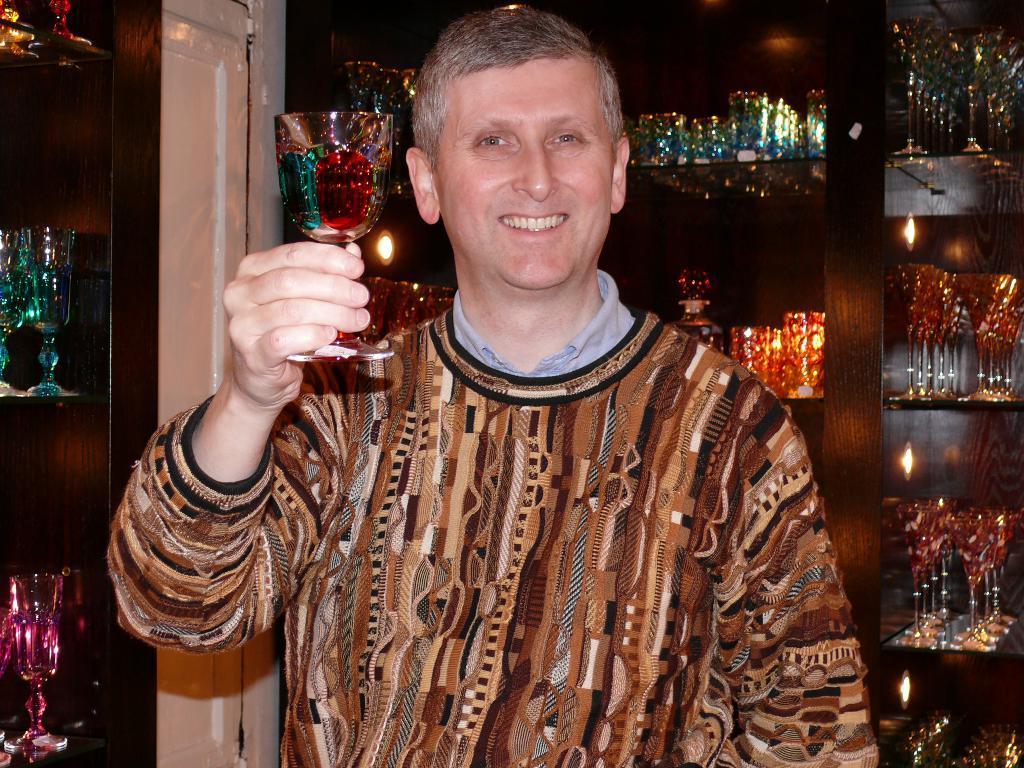How would you summarize this image in a sentence or two? In this image there is a person holding a glass in his hand. Background there are shelves arranged with glasses in it. 